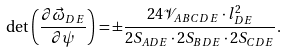Convert formula to latex. <formula><loc_0><loc_0><loc_500><loc_500>\det \left ( \frac { \partial \vec { \omega } _ { D E } } { \partial \psi } \right ) = \pm \frac { 2 4 \mathcal { V } _ { A B C D E } \cdot l _ { D E } ^ { 2 } } { 2 S _ { A D E } \cdot 2 S _ { B D E } \cdot 2 S _ { C D E } } .</formula> 